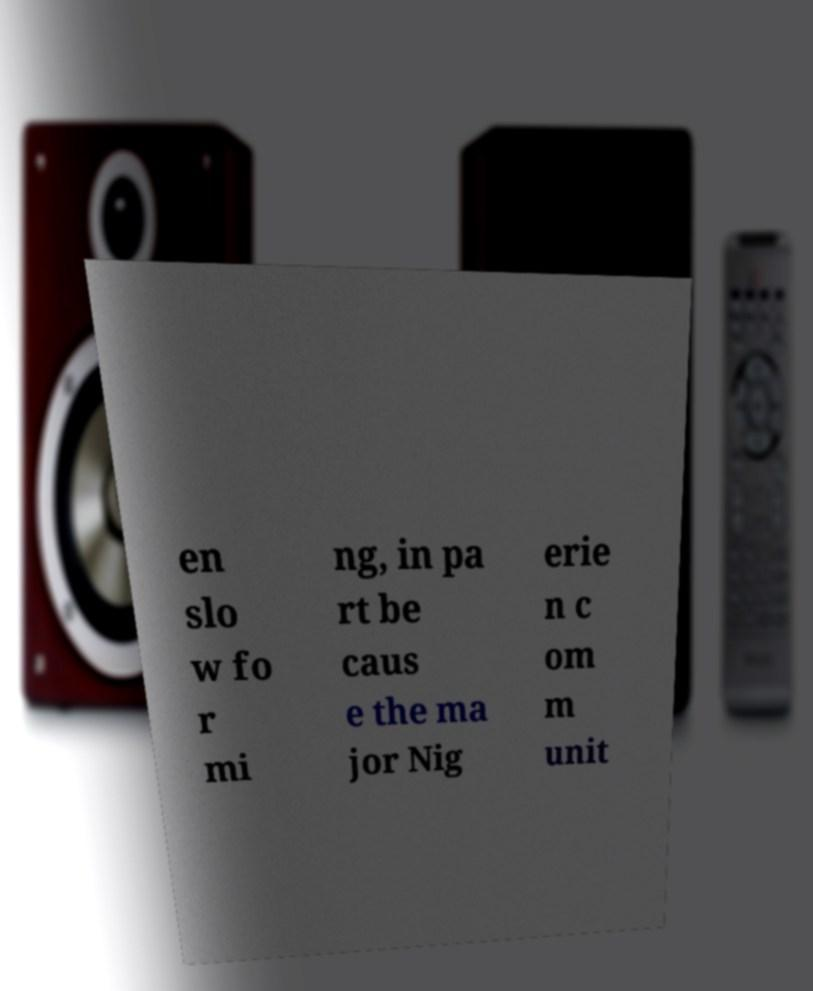For documentation purposes, I need the text within this image transcribed. Could you provide that? en slo w fo r mi ng, in pa rt be caus e the ma jor Nig erie n c om m unit 